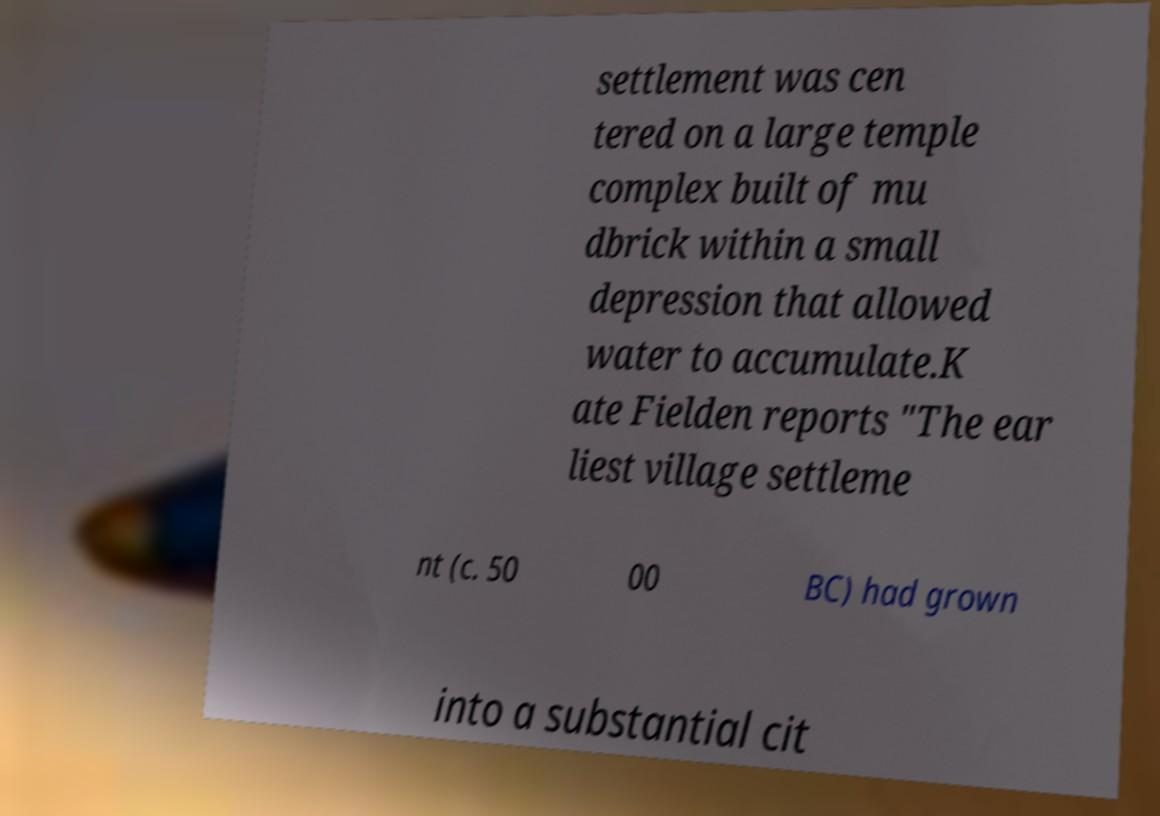Could you assist in decoding the text presented in this image and type it out clearly? settlement was cen tered on a large temple complex built of mu dbrick within a small depression that allowed water to accumulate.K ate Fielden reports "The ear liest village settleme nt (c. 50 00 BC) had grown into a substantial cit 